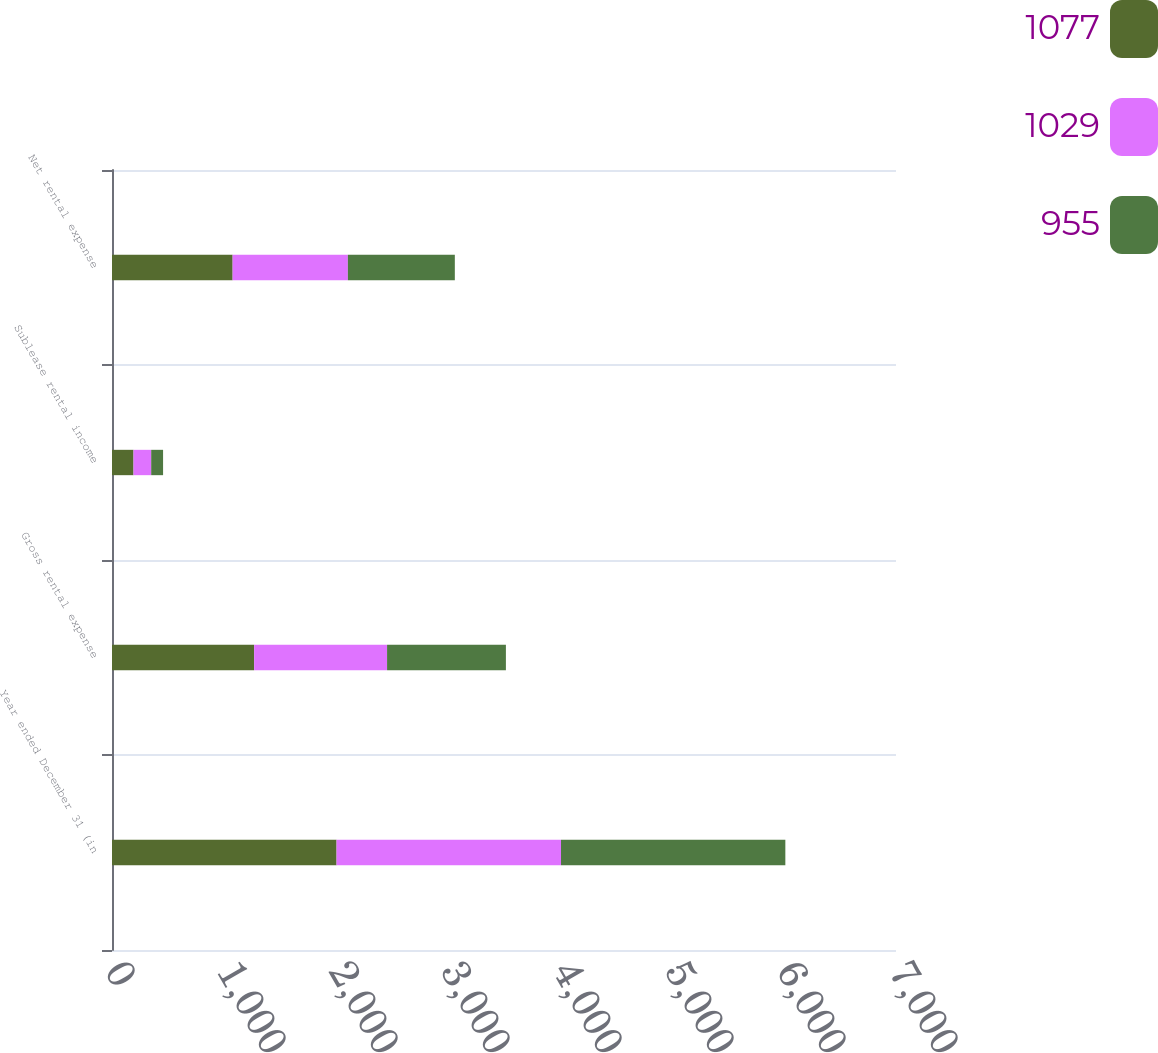Convert chart. <chart><loc_0><loc_0><loc_500><loc_500><stacked_bar_chart><ecel><fcel>Year ended December 31 (in<fcel>Gross rental expense<fcel>Sublease rental income<fcel>Net rental expense<nl><fcel>1077<fcel>2005<fcel>1269<fcel>192<fcel>1077<nl><fcel>1029<fcel>2004<fcel>1187<fcel>158<fcel>1029<nl><fcel>955<fcel>2003<fcel>1061<fcel>106<fcel>955<nl></chart> 